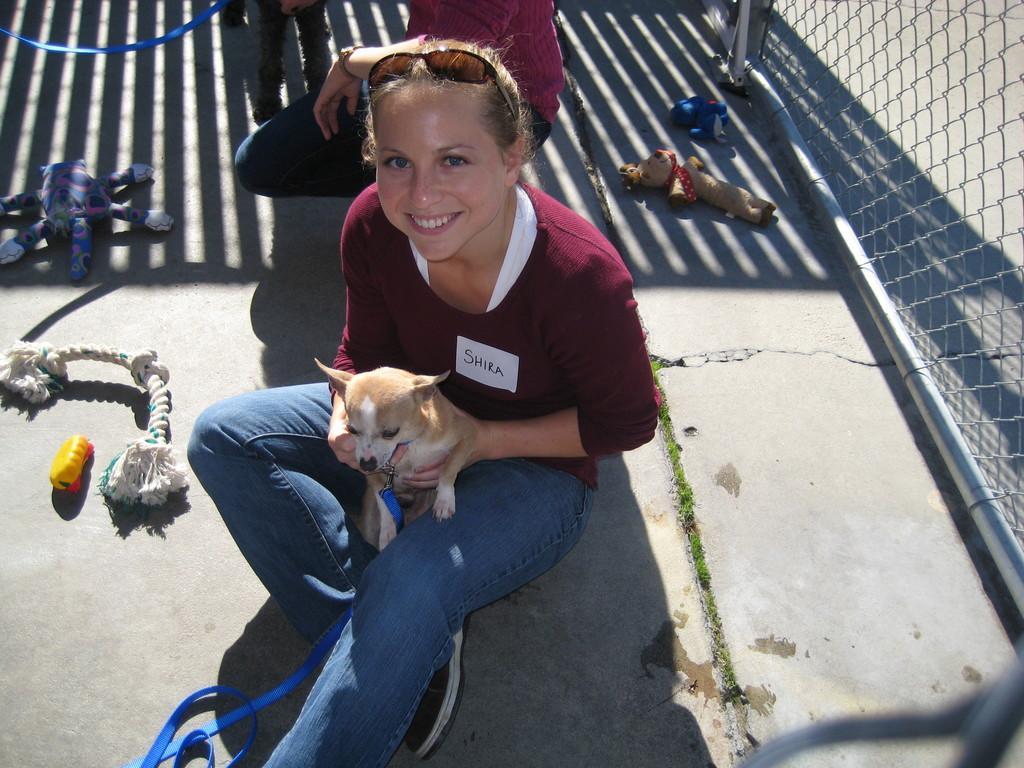How would you summarize this image in a sentence or two? In this picture there is a woman who is holding a dog. She is sitting on the floor near to the fencing. At the top I can see another woman who is wearing t-shirt, trouser and watch. Beside her I can see the bags, ropes, toys and other objects. 